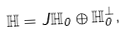<formula> <loc_0><loc_0><loc_500><loc_500>\mathbb { H } = J \mathbb { H } _ { 0 } \oplus \mathbb { H } _ { 0 } ^ { \perp } ,</formula> 